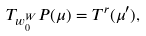Convert formula to latex. <formula><loc_0><loc_0><loc_500><loc_500>& { T } _ { w _ { 0 } ^ { W } } P ( \mu ) = T ^ { r } ( \mu ^ { \prime } ) ,</formula> 